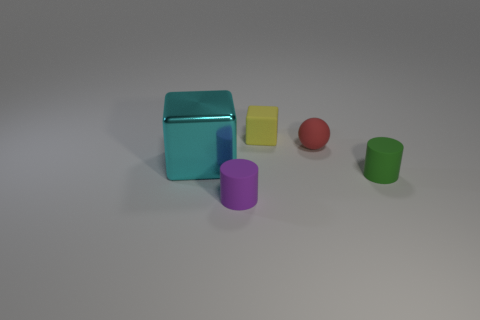Do the cyan object and the purple cylinder have the same size?
Your answer should be very brief. No. What color is the cube on the right side of the metal thing?
Your answer should be very brief. Yellow. What is the size of the purple cylinder that is made of the same material as the red ball?
Your answer should be compact. Small. Do the purple cylinder and the cylinder on the right side of the rubber cube have the same size?
Your answer should be compact. Yes. There is a block that is behind the big cyan shiny object; what is its material?
Give a very brief answer. Rubber. How many cubes are behind the block that is on the right side of the large metal object?
Your answer should be very brief. 0. Are there any small red objects of the same shape as the cyan object?
Provide a succinct answer. No. There is a rubber cylinder that is behind the purple rubber cylinder; is its size the same as the block that is to the right of the big metal cube?
Your answer should be very brief. Yes. What is the shape of the thing that is left of the cylinder in front of the small green rubber thing?
Your response must be concise. Cube. How many yellow shiny cylinders are the same size as the matte block?
Offer a terse response. 0. 